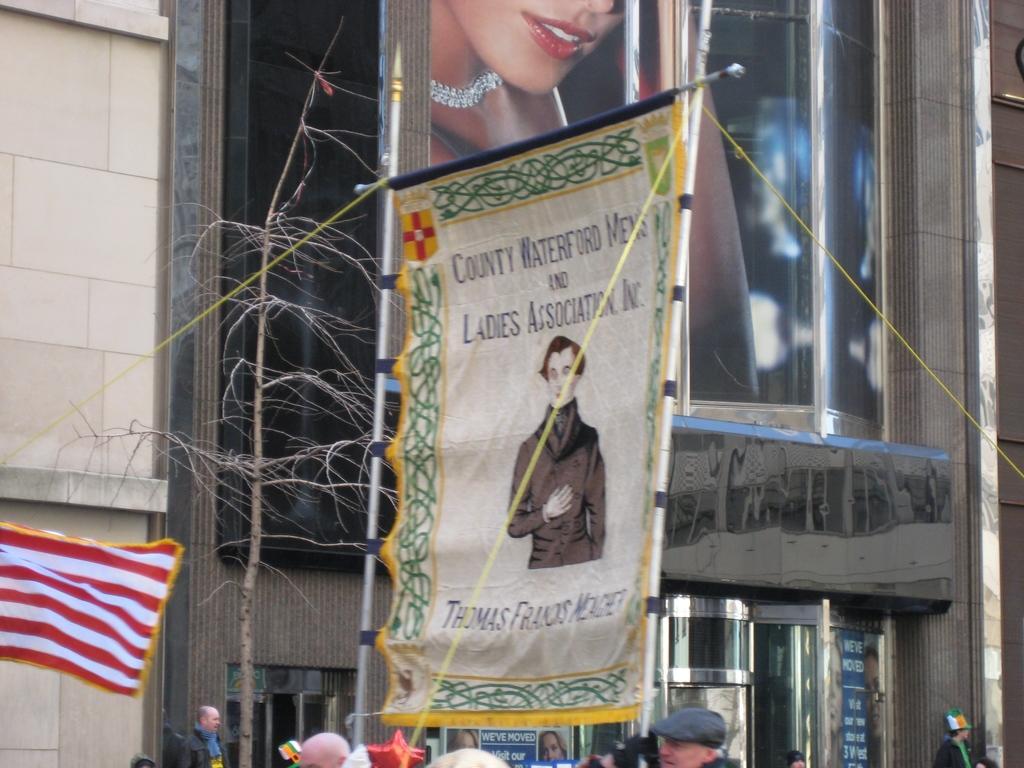Please provide a concise description of this image. In this image we can see there is a poster of a man in the middle and at the bottom there are some people are there, 